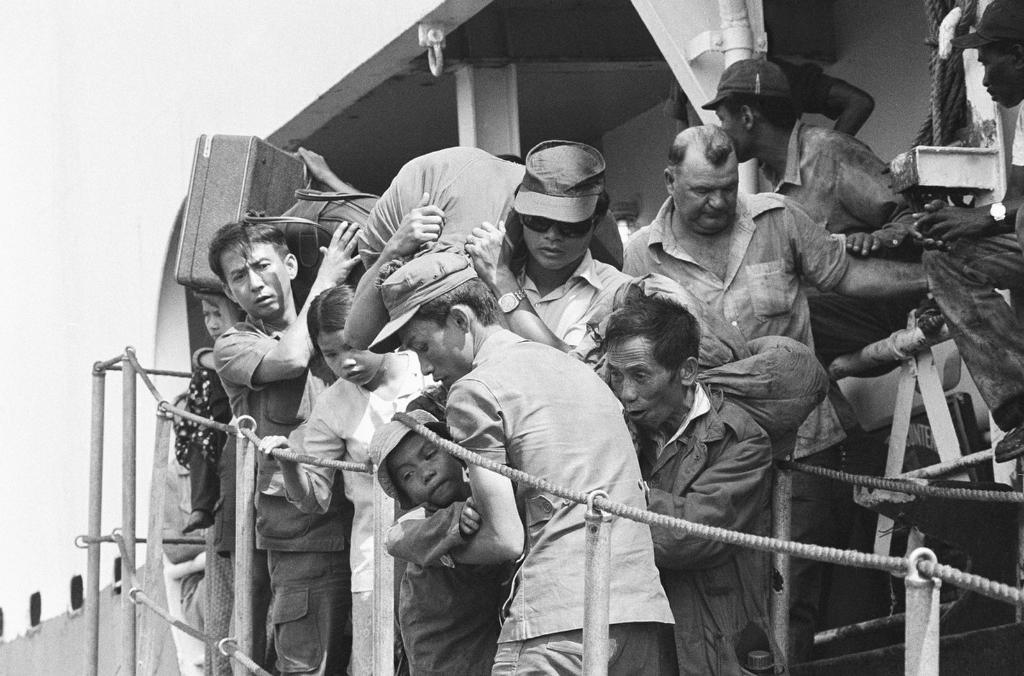How many people are in the image? There is a group of people in the image, but the exact number is not specified. What are some of the people doing in the image? Some of the people are carrying luggage. What type of coat is the thing wearing in the image? There is no "thing" wearing a coat in the image, as the image only features a group of people. 